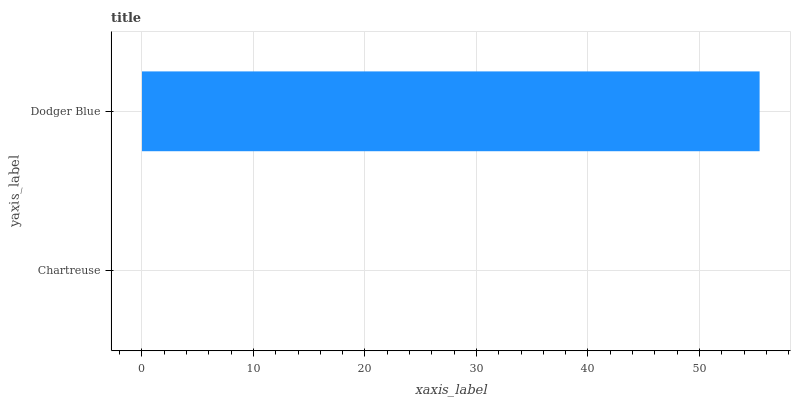Is Chartreuse the minimum?
Answer yes or no. Yes. Is Dodger Blue the maximum?
Answer yes or no. Yes. Is Dodger Blue the minimum?
Answer yes or no. No. Is Dodger Blue greater than Chartreuse?
Answer yes or no. Yes. Is Chartreuse less than Dodger Blue?
Answer yes or no. Yes. Is Chartreuse greater than Dodger Blue?
Answer yes or no. No. Is Dodger Blue less than Chartreuse?
Answer yes or no. No. Is Dodger Blue the high median?
Answer yes or no. Yes. Is Chartreuse the low median?
Answer yes or no. Yes. Is Chartreuse the high median?
Answer yes or no. No. Is Dodger Blue the low median?
Answer yes or no. No. 